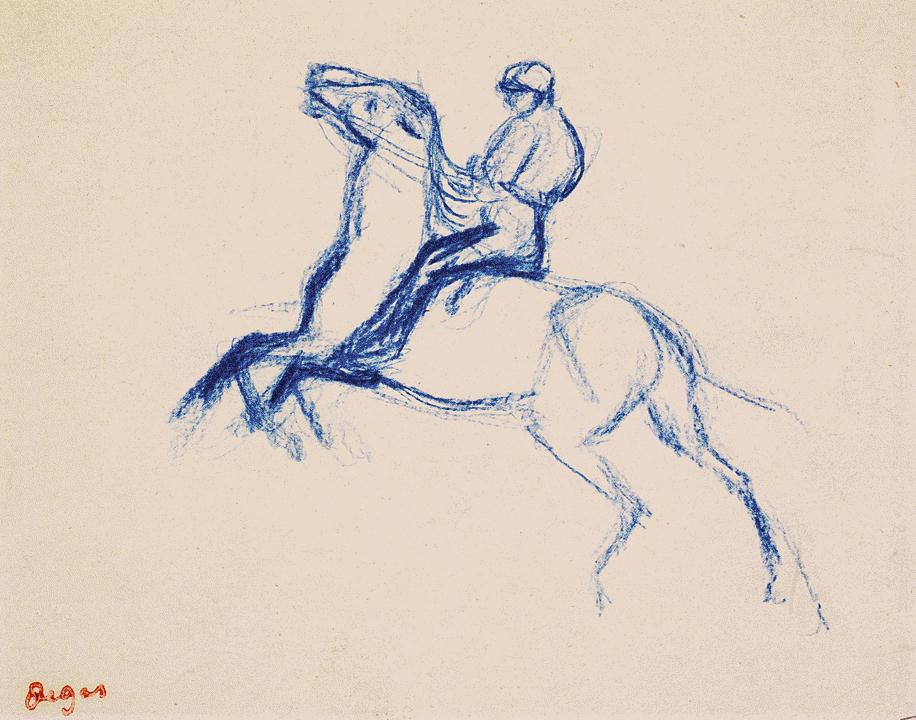What emotion does this sketch convey? The sketch portrays a feeling of dynamic energy and collaboration between the horse and rider. The rearing pose of the horse suggests a mixture of excitement and perhaps a hint of tension, while the rider's firm grip implies control and partnership. The dominant blue color evokes a sense of calm intensity, adding to the overall dramatic effect. Why do you think the artist chose to use only blue for this sketch? The artist’s choice to use only blue may have been driven by the desire to focus on the emotions and movement in the scene rather than being confined by realistic color constraints. Blue can evoke feelings of tranquility, depth, and introspection, possibly reflecting the intensity of the moment and the connection between the horse and rider. It also sharply contrasts with the white background, amplifying the visual impact of the sketch. Imagine you are the rider in this image. Describe your experience in detail. As the rider, I feel an exhilarating rush of adrenaline as my horse rears up beneath me. I grip the reins tightly, feeling the raw power and energy of this majestic creature coursing through my hands. My heart pounds in sync with the rhythm of the powerful muscles straining against my legs. The world feels both incredibly vivid and profoundly distant, the stark blue of the horse and my own form blending seamlessly into one fluid motion. Every sense is heightened; I hear the sharp intake of breath from my horse, smell the earthy scent of its sweat, and taste the exhilaration on my tongue. In this suspended moment of heightened reality, there is an unspoken bond between us, a merging of wills and spirits, as we move as one through this intense and dynamic experience. Create a short poetic interpretation of this artwork. In shades of blue, in strokes so bold,
A tale of strength and grace is told.
A horse rears up, an arc in flight,
A dance of shadow, form, and light.
Rider and steed, in unity grand,
Traverse through skies and upon the land.
In that blue hued, eternal frame,
They live forever, wild and untamed. 